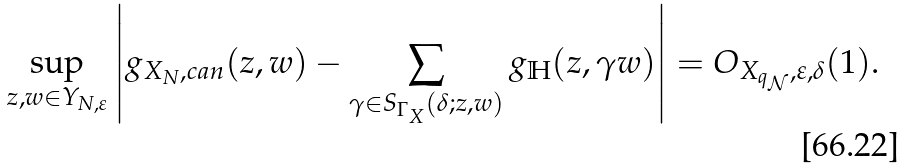<formula> <loc_0><loc_0><loc_500><loc_500>\sup _ { z , w \in Y _ { N , \varepsilon } } \left | g _ { X _ { N } , c a n } ( z , w ) - \sum _ { \gamma \in S _ { \Gamma _ { X } } ( \delta ; z , w ) } g _ { \mathbb { H } } ( z , \gamma w ) \right | = O _ { X _ { q _ { \mathcal { N } } } , \varepsilon , \delta } ( 1 ) .</formula> 